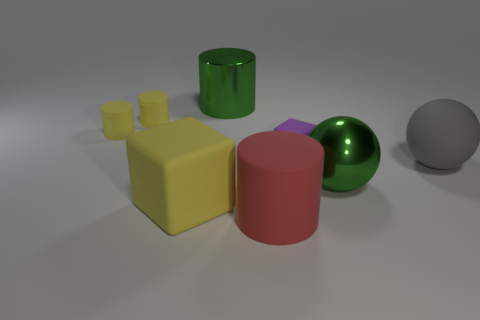If we were to describe the colors present in this image, how would we do it? The image features a palette with a mix of muted and vibrant colors. The primary colors present are a bright yellow for the cubes, glossy green for the cylinder, a reflective green for the sphere, a muted gray for the ball to the right, and a matte purple for the low poly count object. These colors contrast well against the neutral off-white background. 